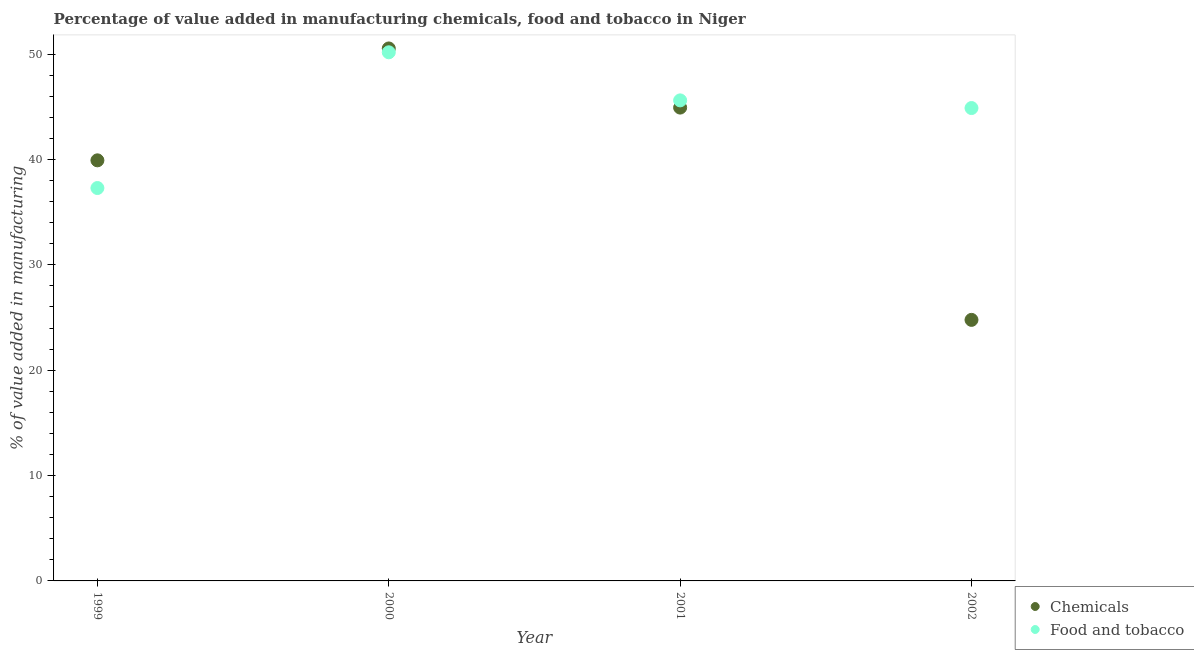Is the number of dotlines equal to the number of legend labels?
Give a very brief answer. Yes. What is the value added by manufacturing food and tobacco in 2001?
Make the answer very short. 45.6. Across all years, what is the maximum value added by manufacturing food and tobacco?
Provide a short and direct response. 50.16. Across all years, what is the minimum value added by manufacturing food and tobacco?
Ensure brevity in your answer.  37.28. What is the total value added by manufacturing food and tobacco in the graph?
Make the answer very short. 177.92. What is the difference between the value added by manufacturing food and tobacco in 1999 and that in 2001?
Provide a short and direct response. -8.32. What is the difference between the value added by manufacturing food and tobacco in 1999 and the value added by  manufacturing chemicals in 2002?
Your answer should be very brief. 12.51. What is the average value added by manufacturing food and tobacco per year?
Offer a terse response. 44.48. In the year 2002, what is the difference between the value added by manufacturing food and tobacco and value added by  manufacturing chemicals?
Offer a very short reply. 20.1. In how many years, is the value added by manufacturing food and tobacco greater than 16 %?
Offer a very short reply. 4. What is the ratio of the value added by  manufacturing chemicals in 1999 to that in 2001?
Offer a very short reply. 0.89. What is the difference between the highest and the second highest value added by  manufacturing chemicals?
Your answer should be very brief. 5.61. What is the difference between the highest and the lowest value added by manufacturing food and tobacco?
Give a very brief answer. 12.88. Is the sum of the value added by manufacturing food and tobacco in 2000 and 2002 greater than the maximum value added by  manufacturing chemicals across all years?
Your response must be concise. Yes. Does the value added by manufacturing food and tobacco monotonically increase over the years?
Your answer should be compact. No. How many dotlines are there?
Offer a very short reply. 2. What is the difference between two consecutive major ticks on the Y-axis?
Ensure brevity in your answer.  10. Are the values on the major ticks of Y-axis written in scientific E-notation?
Ensure brevity in your answer.  No. Does the graph contain any zero values?
Provide a succinct answer. No. Where does the legend appear in the graph?
Provide a succinct answer. Bottom right. How many legend labels are there?
Provide a short and direct response. 2. What is the title of the graph?
Ensure brevity in your answer.  Percentage of value added in manufacturing chemicals, food and tobacco in Niger. Does "Short-term debt" appear as one of the legend labels in the graph?
Your answer should be very brief. No. What is the label or title of the Y-axis?
Provide a succinct answer. % of value added in manufacturing. What is the % of value added in manufacturing of Chemicals in 1999?
Provide a succinct answer. 39.91. What is the % of value added in manufacturing of Food and tobacco in 1999?
Offer a terse response. 37.28. What is the % of value added in manufacturing in Chemicals in 2000?
Give a very brief answer. 50.53. What is the % of value added in manufacturing of Food and tobacco in 2000?
Provide a short and direct response. 50.16. What is the % of value added in manufacturing in Chemicals in 2001?
Your answer should be very brief. 44.92. What is the % of value added in manufacturing of Food and tobacco in 2001?
Provide a short and direct response. 45.6. What is the % of value added in manufacturing in Chemicals in 2002?
Ensure brevity in your answer.  24.77. What is the % of value added in manufacturing in Food and tobacco in 2002?
Your answer should be very brief. 44.87. Across all years, what is the maximum % of value added in manufacturing in Chemicals?
Ensure brevity in your answer.  50.53. Across all years, what is the maximum % of value added in manufacturing in Food and tobacco?
Your answer should be very brief. 50.16. Across all years, what is the minimum % of value added in manufacturing of Chemicals?
Your response must be concise. 24.77. Across all years, what is the minimum % of value added in manufacturing of Food and tobacco?
Give a very brief answer. 37.28. What is the total % of value added in manufacturing of Chemicals in the graph?
Offer a very short reply. 160.13. What is the total % of value added in manufacturing of Food and tobacco in the graph?
Provide a succinct answer. 177.92. What is the difference between the % of value added in manufacturing of Chemicals in 1999 and that in 2000?
Your answer should be compact. -10.62. What is the difference between the % of value added in manufacturing of Food and tobacco in 1999 and that in 2000?
Your response must be concise. -12.88. What is the difference between the % of value added in manufacturing in Chemicals in 1999 and that in 2001?
Provide a succinct answer. -5.01. What is the difference between the % of value added in manufacturing of Food and tobacco in 1999 and that in 2001?
Your answer should be compact. -8.32. What is the difference between the % of value added in manufacturing of Chemicals in 1999 and that in 2002?
Ensure brevity in your answer.  15.14. What is the difference between the % of value added in manufacturing in Food and tobacco in 1999 and that in 2002?
Offer a very short reply. -7.59. What is the difference between the % of value added in manufacturing in Chemicals in 2000 and that in 2001?
Your answer should be compact. 5.61. What is the difference between the % of value added in manufacturing in Food and tobacco in 2000 and that in 2001?
Ensure brevity in your answer.  4.56. What is the difference between the % of value added in manufacturing of Chemicals in 2000 and that in 2002?
Ensure brevity in your answer.  25.76. What is the difference between the % of value added in manufacturing of Food and tobacco in 2000 and that in 2002?
Ensure brevity in your answer.  5.29. What is the difference between the % of value added in manufacturing in Chemicals in 2001 and that in 2002?
Your response must be concise. 20.14. What is the difference between the % of value added in manufacturing of Food and tobacco in 2001 and that in 2002?
Your answer should be very brief. 0.73. What is the difference between the % of value added in manufacturing in Chemicals in 1999 and the % of value added in manufacturing in Food and tobacco in 2000?
Your answer should be very brief. -10.25. What is the difference between the % of value added in manufacturing of Chemicals in 1999 and the % of value added in manufacturing of Food and tobacco in 2001?
Your answer should be very brief. -5.69. What is the difference between the % of value added in manufacturing of Chemicals in 1999 and the % of value added in manufacturing of Food and tobacco in 2002?
Provide a succinct answer. -4.96. What is the difference between the % of value added in manufacturing of Chemicals in 2000 and the % of value added in manufacturing of Food and tobacco in 2001?
Your response must be concise. 4.93. What is the difference between the % of value added in manufacturing in Chemicals in 2000 and the % of value added in manufacturing in Food and tobacco in 2002?
Your answer should be very brief. 5.66. What is the difference between the % of value added in manufacturing of Chemicals in 2001 and the % of value added in manufacturing of Food and tobacco in 2002?
Your response must be concise. 0.04. What is the average % of value added in manufacturing of Chemicals per year?
Provide a short and direct response. 40.03. What is the average % of value added in manufacturing in Food and tobacco per year?
Your answer should be very brief. 44.48. In the year 1999, what is the difference between the % of value added in manufacturing in Chemicals and % of value added in manufacturing in Food and tobacco?
Your response must be concise. 2.63. In the year 2000, what is the difference between the % of value added in manufacturing of Chemicals and % of value added in manufacturing of Food and tobacco?
Make the answer very short. 0.37. In the year 2001, what is the difference between the % of value added in manufacturing of Chemicals and % of value added in manufacturing of Food and tobacco?
Give a very brief answer. -0.68. In the year 2002, what is the difference between the % of value added in manufacturing in Chemicals and % of value added in manufacturing in Food and tobacco?
Your answer should be very brief. -20.1. What is the ratio of the % of value added in manufacturing of Chemicals in 1999 to that in 2000?
Your answer should be compact. 0.79. What is the ratio of the % of value added in manufacturing in Food and tobacco in 1999 to that in 2000?
Ensure brevity in your answer.  0.74. What is the ratio of the % of value added in manufacturing in Chemicals in 1999 to that in 2001?
Keep it short and to the point. 0.89. What is the ratio of the % of value added in manufacturing in Food and tobacco in 1999 to that in 2001?
Offer a terse response. 0.82. What is the ratio of the % of value added in manufacturing of Chemicals in 1999 to that in 2002?
Your answer should be very brief. 1.61. What is the ratio of the % of value added in manufacturing of Food and tobacco in 1999 to that in 2002?
Provide a short and direct response. 0.83. What is the ratio of the % of value added in manufacturing of Chemicals in 2000 to that in 2001?
Provide a succinct answer. 1.12. What is the ratio of the % of value added in manufacturing of Food and tobacco in 2000 to that in 2001?
Keep it short and to the point. 1.1. What is the ratio of the % of value added in manufacturing in Chemicals in 2000 to that in 2002?
Your answer should be very brief. 2.04. What is the ratio of the % of value added in manufacturing in Food and tobacco in 2000 to that in 2002?
Give a very brief answer. 1.12. What is the ratio of the % of value added in manufacturing of Chemicals in 2001 to that in 2002?
Your answer should be compact. 1.81. What is the ratio of the % of value added in manufacturing of Food and tobacco in 2001 to that in 2002?
Offer a very short reply. 1.02. What is the difference between the highest and the second highest % of value added in manufacturing in Chemicals?
Keep it short and to the point. 5.61. What is the difference between the highest and the second highest % of value added in manufacturing of Food and tobacco?
Keep it short and to the point. 4.56. What is the difference between the highest and the lowest % of value added in manufacturing of Chemicals?
Provide a succinct answer. 25.76. What is the difference between the highest and the lowest % of value added in manufacturing in Food and tobacco?
Offer a very short reply. 12.88. 